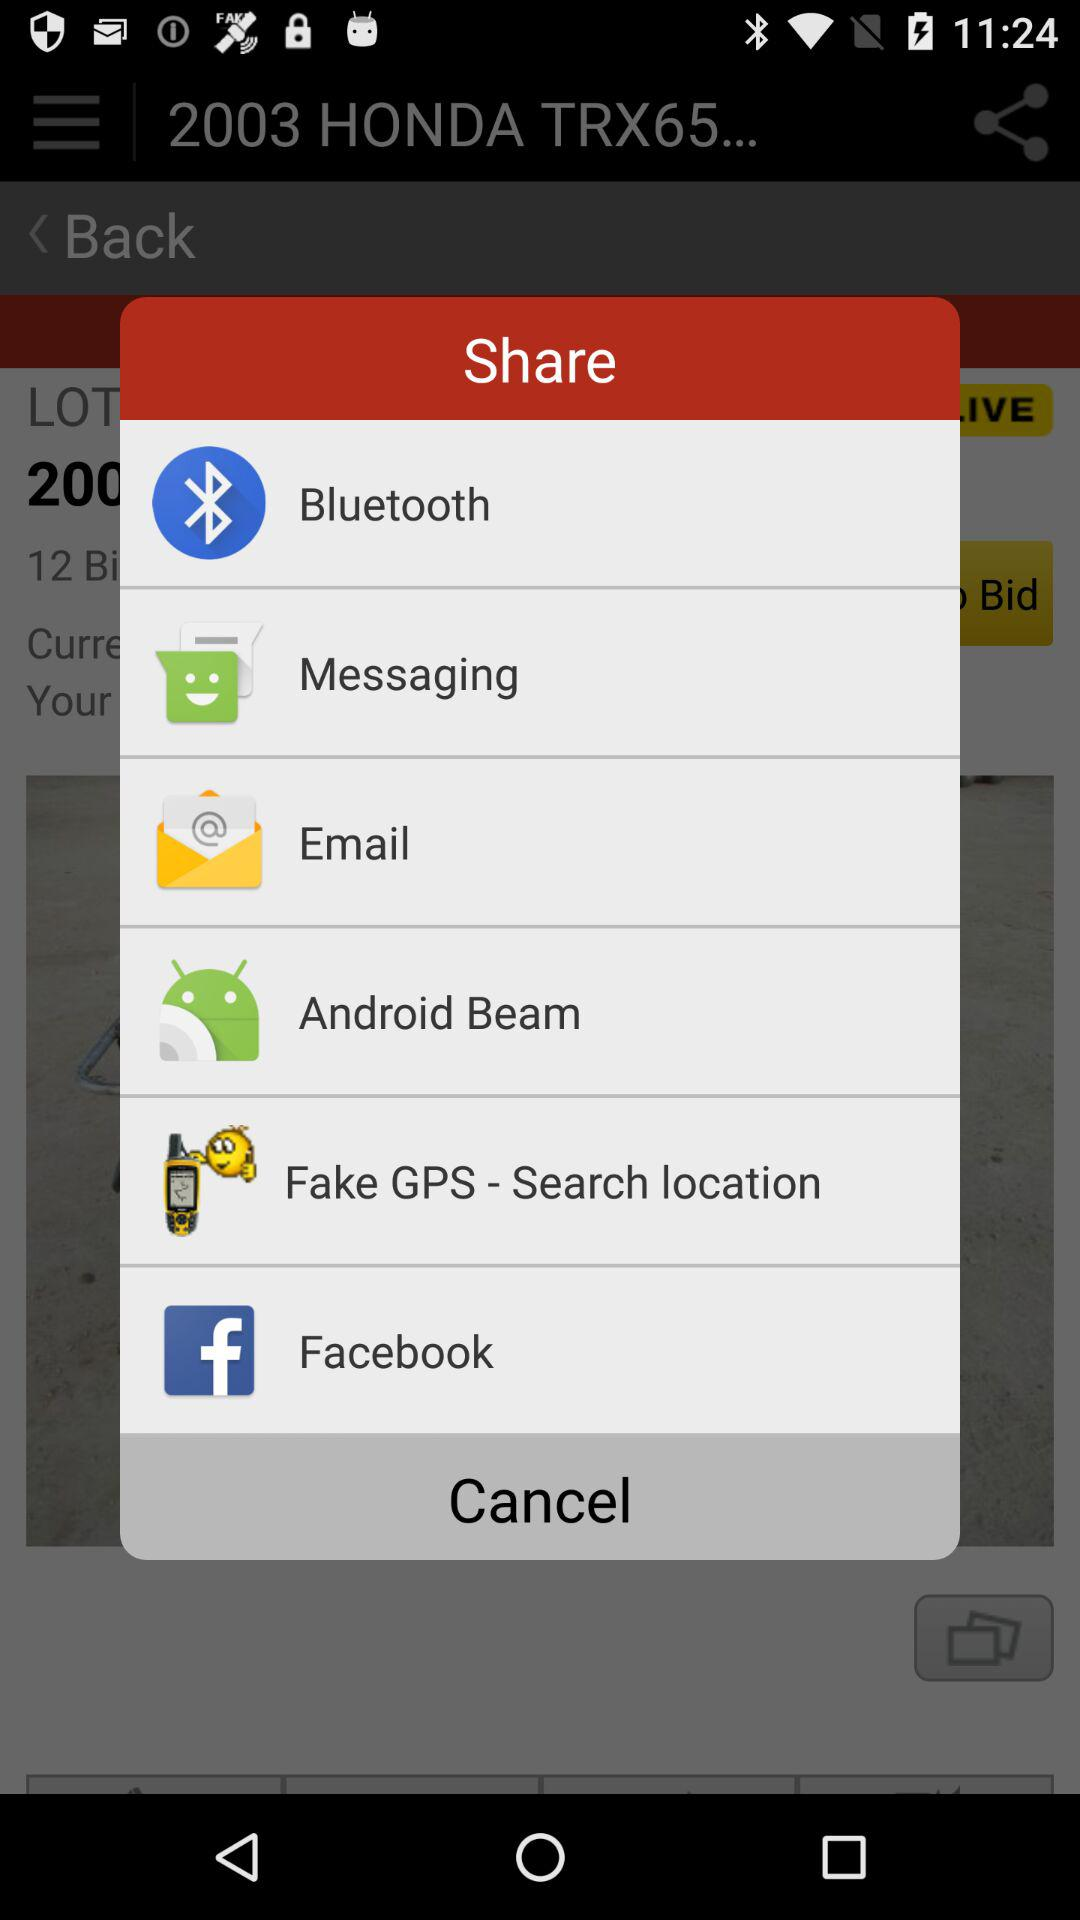Through which application can we share? You can share through "Bluetooth", "Messaging", "Email", "Android Beam", "Fake GPS - Search location" and "Facebook". 